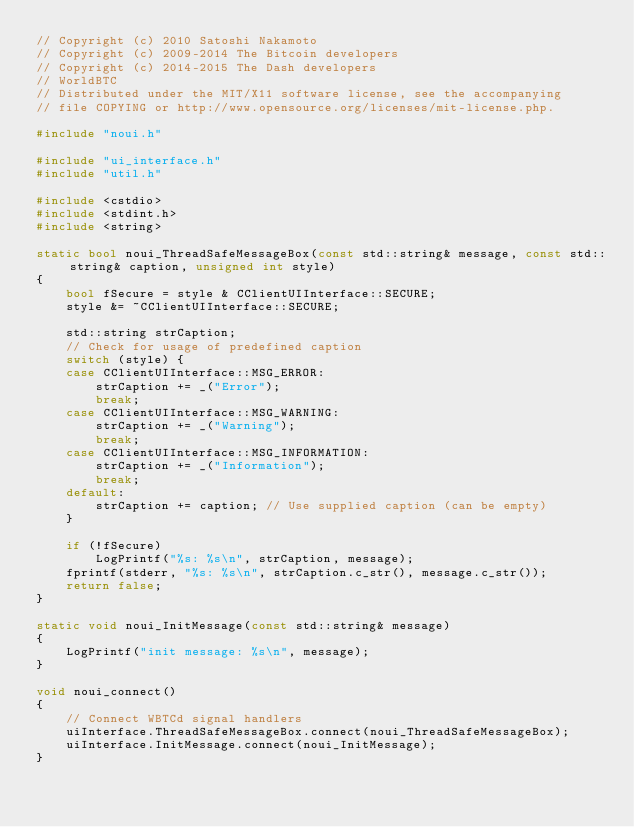<code> <loc_0><loc_0><loc_500><loc_500><_C++_>// Copyright (c) 2010 Satoshi Nakamoto
// Copyright (c) 2009-2014 The Bitcoin developers
// Copyright (c) 2014-2015 The Dash developers
// WorldBTC
// Distributed under the MIT/X11 software license, see the accompanying
// file COPYING or http://www.opensource.org/licenses/mit-license.php.

#include "noui.h"

#include "ui_interface.h"
#include "util.h"

#include <cstdio>
#include <stdint.h>
#include <string>

static bool noui_ThreadSafeMessageBox(const std::string& message, const std::string& caption, unsigned int style)
{
    bool fSecure = style & CClientUIInterface::SECURE;
    style &= ~CClientUIInterface::SECURE;

    std::string strCaption;
    // Check for usage of predefined caption
    switch (style) {
    case CClientUIInterface::MSG_ERROR:
        strCaption += _("Error");
        break;
    case CClientUIInterface::MSG_WARNING:
        strCaption += _("Warning");
        break;
    case CClientUIInterface::MSG_INFORMATION:
        strCaption += _("Information");
        break;
    default:
        strCaption += caption; // Use supplied caption (can be empty)
    }

    if (!fSecure)
        LogPrintf("%s: %s\n", strCaption, message);
    fprintf(stderr, "%s: %s\n", strCaption.c_str(), message.c_str());
    return false;
}

static void noui_InitMessage(const std::string& message)
{
    LogPrintf("init message: %s\n", message);
}

void noui_connect()
{
    // Connect WBTCd signal handlers
    uiInterface.ThreadSafeMessageBox.connect(noui_ThreadSafeMessageBox);
    uiInterface.InitMessage.connect(noui_InitMessage);
}
</code> 